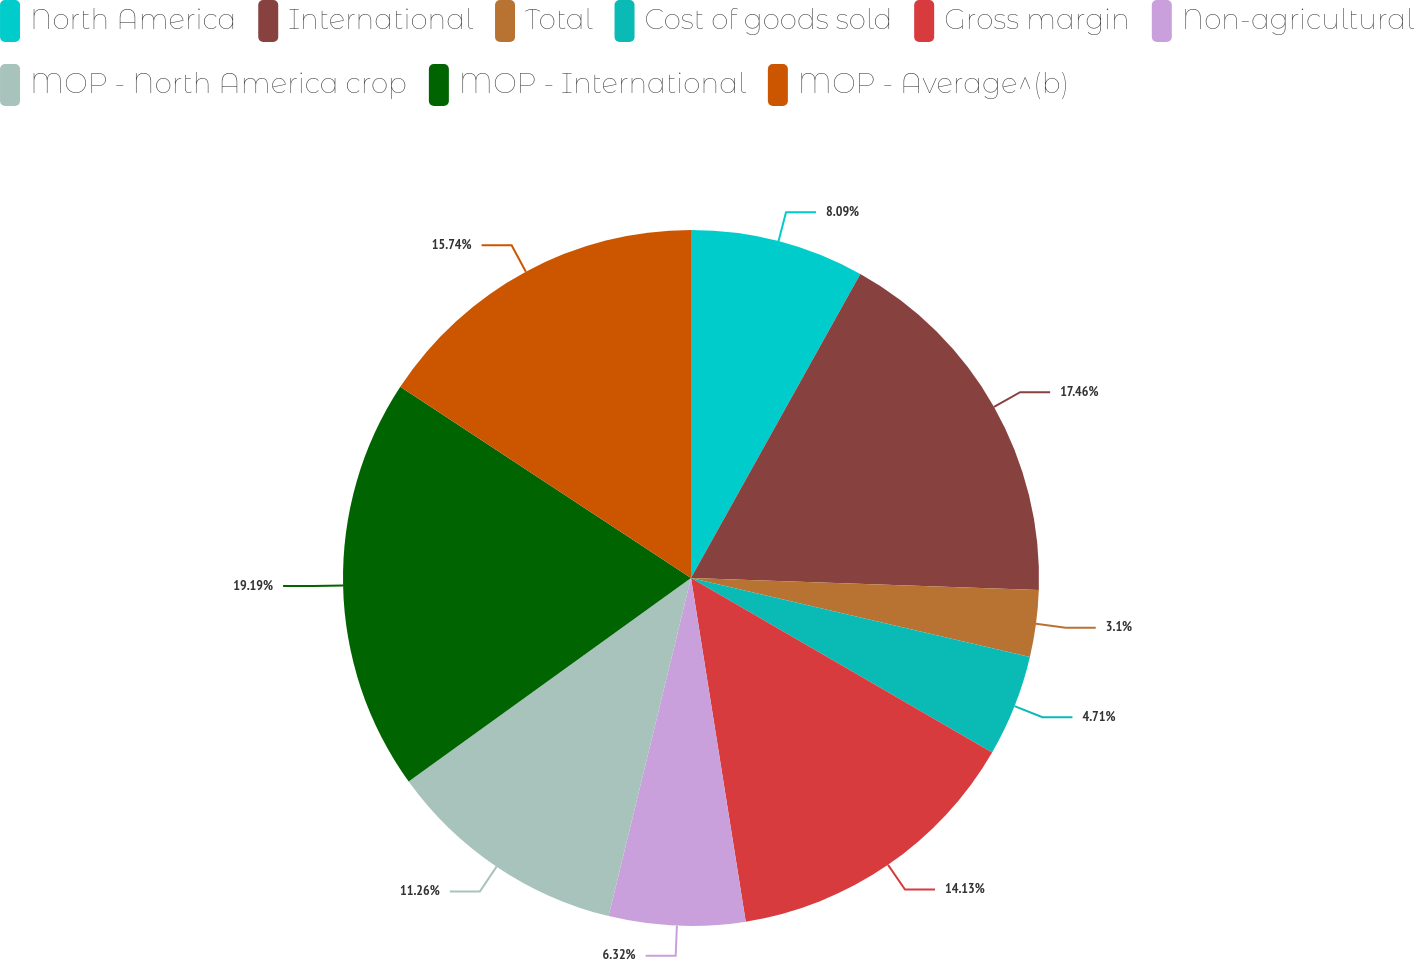Convert chart to OTSL. <chart><loc_0><loc_0><loc_500><loc_500><pie_chart><fcel>North America<fcel>International<fcel>Total<fcel>Cost of goods sold<fcel>Gross margin<fcel>Non-agricultural<fcel>MOP - North America crop<fcel>MOP - International<fcel>MOP - Average^(b)<nl><fcel>8.09%<fcel>17.46%<fcel>3.1%<fcel>4.71%<fcel>14.13%<fcel>6.32%<fcel>11.26%<fcel>19.2%<fcel>15.74%<nl></chart> 